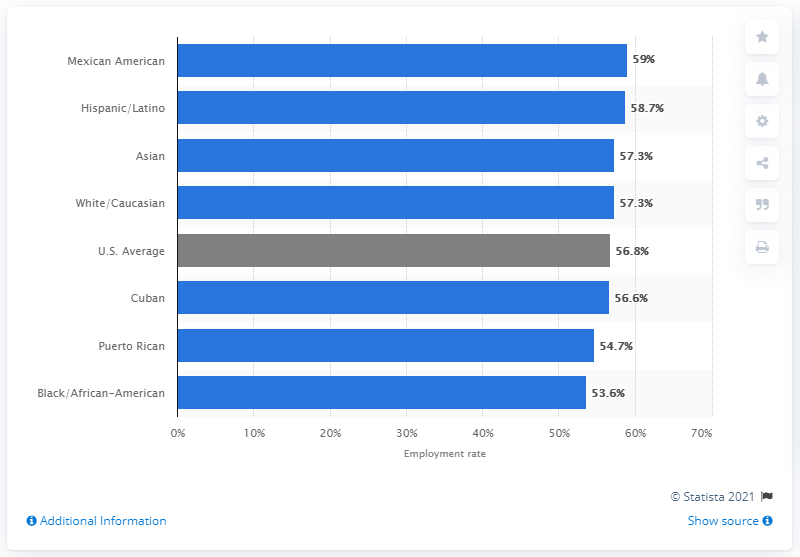Identify some key points in this picture. According to the 2020 employment data, 57.3% of the Asian community was employed. 